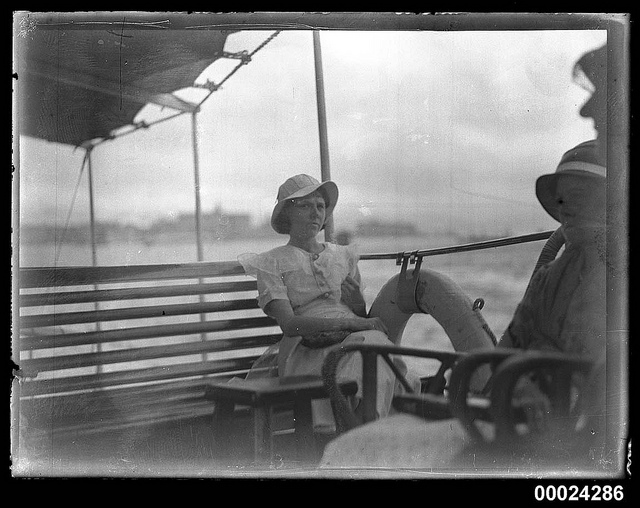Please transcribe the text information in this image. 00024286 